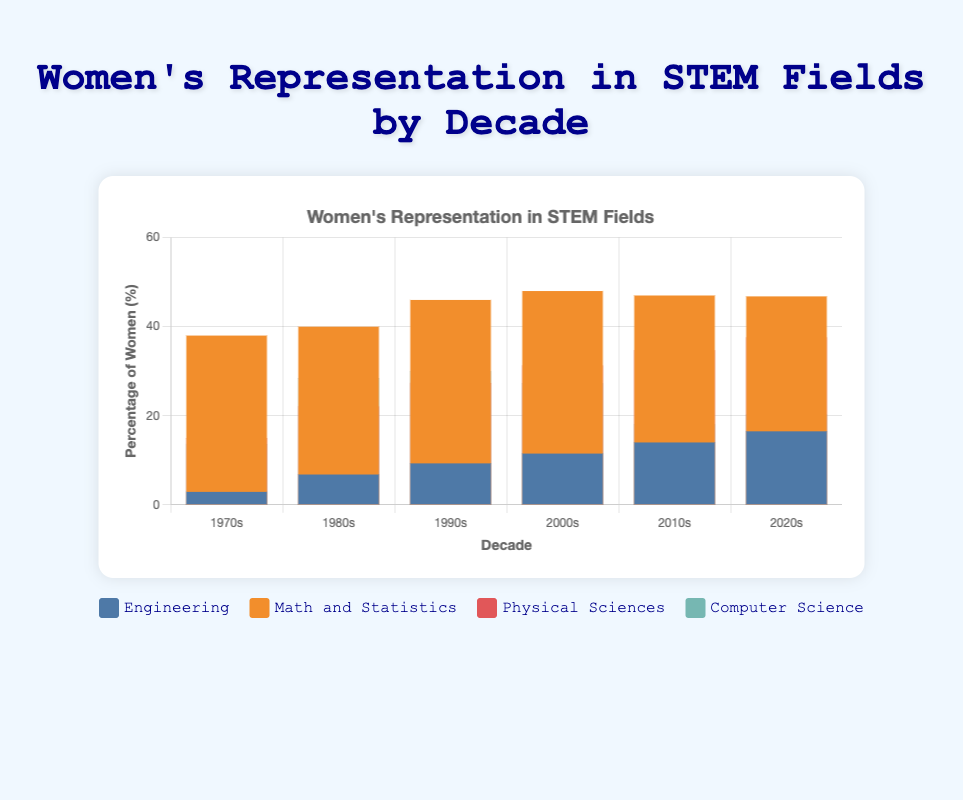Which field had the largest increase in the percentage of women from the 1970s to the 2020s? The field with the largest increase in the percentage of women would be calculated by subtracting the 1970s percentage from the 2020s percentage for each field, then comparing the results. Engineering increased from 2.9% to 16.5% (a 13.6% increase), Math and Statistics from 38% to 46.8% (an 8.8% increase), Physical Sciences from 14.9% to 37.5% (a 22.6% increase), and Computer Science from 13.6% to 20.2% (a 6.6% increase). The Physical Sciences saw the largest increase.
Answer: Physical Sciences What is the trend in the representation of women in engineering over the decades? To determine the trend, one would look at the percentages of women in engineering for each decade. From the chart's data: 1970s (2.9%), 1980s (6.8%), 1990s (9.3%), 2000s (11.5%), 2010s (14%), and 2020s (16.5%). The trend shows a consistent increase in the representation of women in engineering across all decades.
Answer: Increasing Which decade saw the highest percentage of women in Computer Science? To answer this question, check the percentage of women in Computer Science for each decade. The highest percentage was 29.9% in the 1990s.
Answer: 1990s Compare the percentage of women in Physical Sciences to Engineering in the 2020s. Which field had a higher representation? For the 2020s, examine the percentages for Physical Sciences and Engineering. The Physical Sciences had 37.5% while Engineering had 16.5%. The Physical Sciences had a higher representation.
Answer: Physical Sciences What percentage of women were in Math and Statistics in the 2000s compared to the 2010s? Look at the chart data for these two decades: The percentage of women in Math and Statistics remained quite consistent, 48% in the 2000s and 47% in the 2010s. The decrease is 1%.
Answer: 1% decrease Which field showed the slowest growth in the representation of women between 1970 and 2020? Calculate the growth for each field: Engineering (16.5% - 2.9% = 13.6%), Math and Statistics (46.8% - 38% = 8.8%), Physical Sciences (37.5% - 14.9% = 22.6%), Computer Science (20.2% - 13.6% = 6.6%). Computer Science showed the slowest growth.
Answer: Computer Science In which decade did the percentage of women in Math and Statistics first reach or exceed 40%? Inspect the data for Math and Statistics over the decades: It reached 40% in the 1980s.
Answer: 1980s 